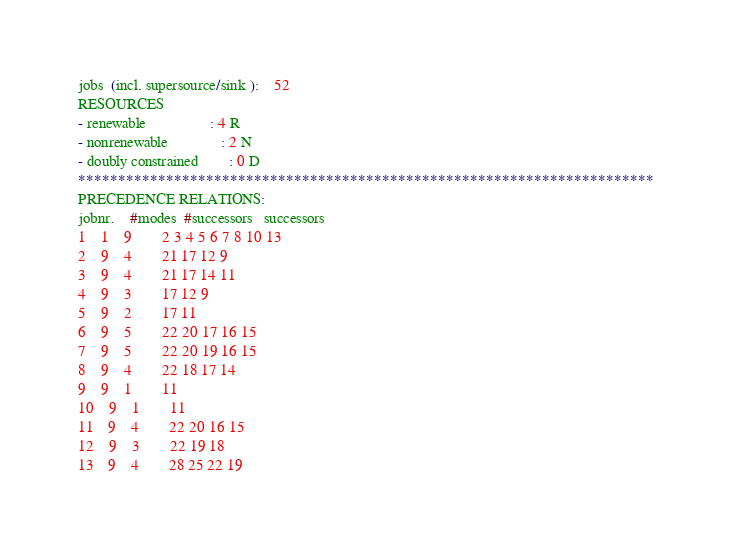Convert code to text. <code><loc_0><loc_0><loc_500><loc_500><_ObjectiveC_>jobs  (incl. supersource/sink ):	52
RESOURCES
- renewable                 : 4 R
- nonrenewable              : 2 N
- doubly constrained        : 0 D
************************************************************************
PRECEDENCE RELATIONS:
jobnr.    #modes  #successors   successors
1	1	9		2 3 4 5 6 7 8 10 13 
2	9	4		21 17 12 9 
3	9	4		21 17 14 11 
4	9	3		17 12 9 
5	9	2		17 11 
6	9	5		22 20 17 16 15 
7	9	5		22 20 19 16 15 
8	9	4		22 18 17 14 
9	9	1		11 
10	9	1		11 
11	9	4		22 20 16 15 
12	9	3		22 19 18 
13	9	4		28 25 22 19 </code> 